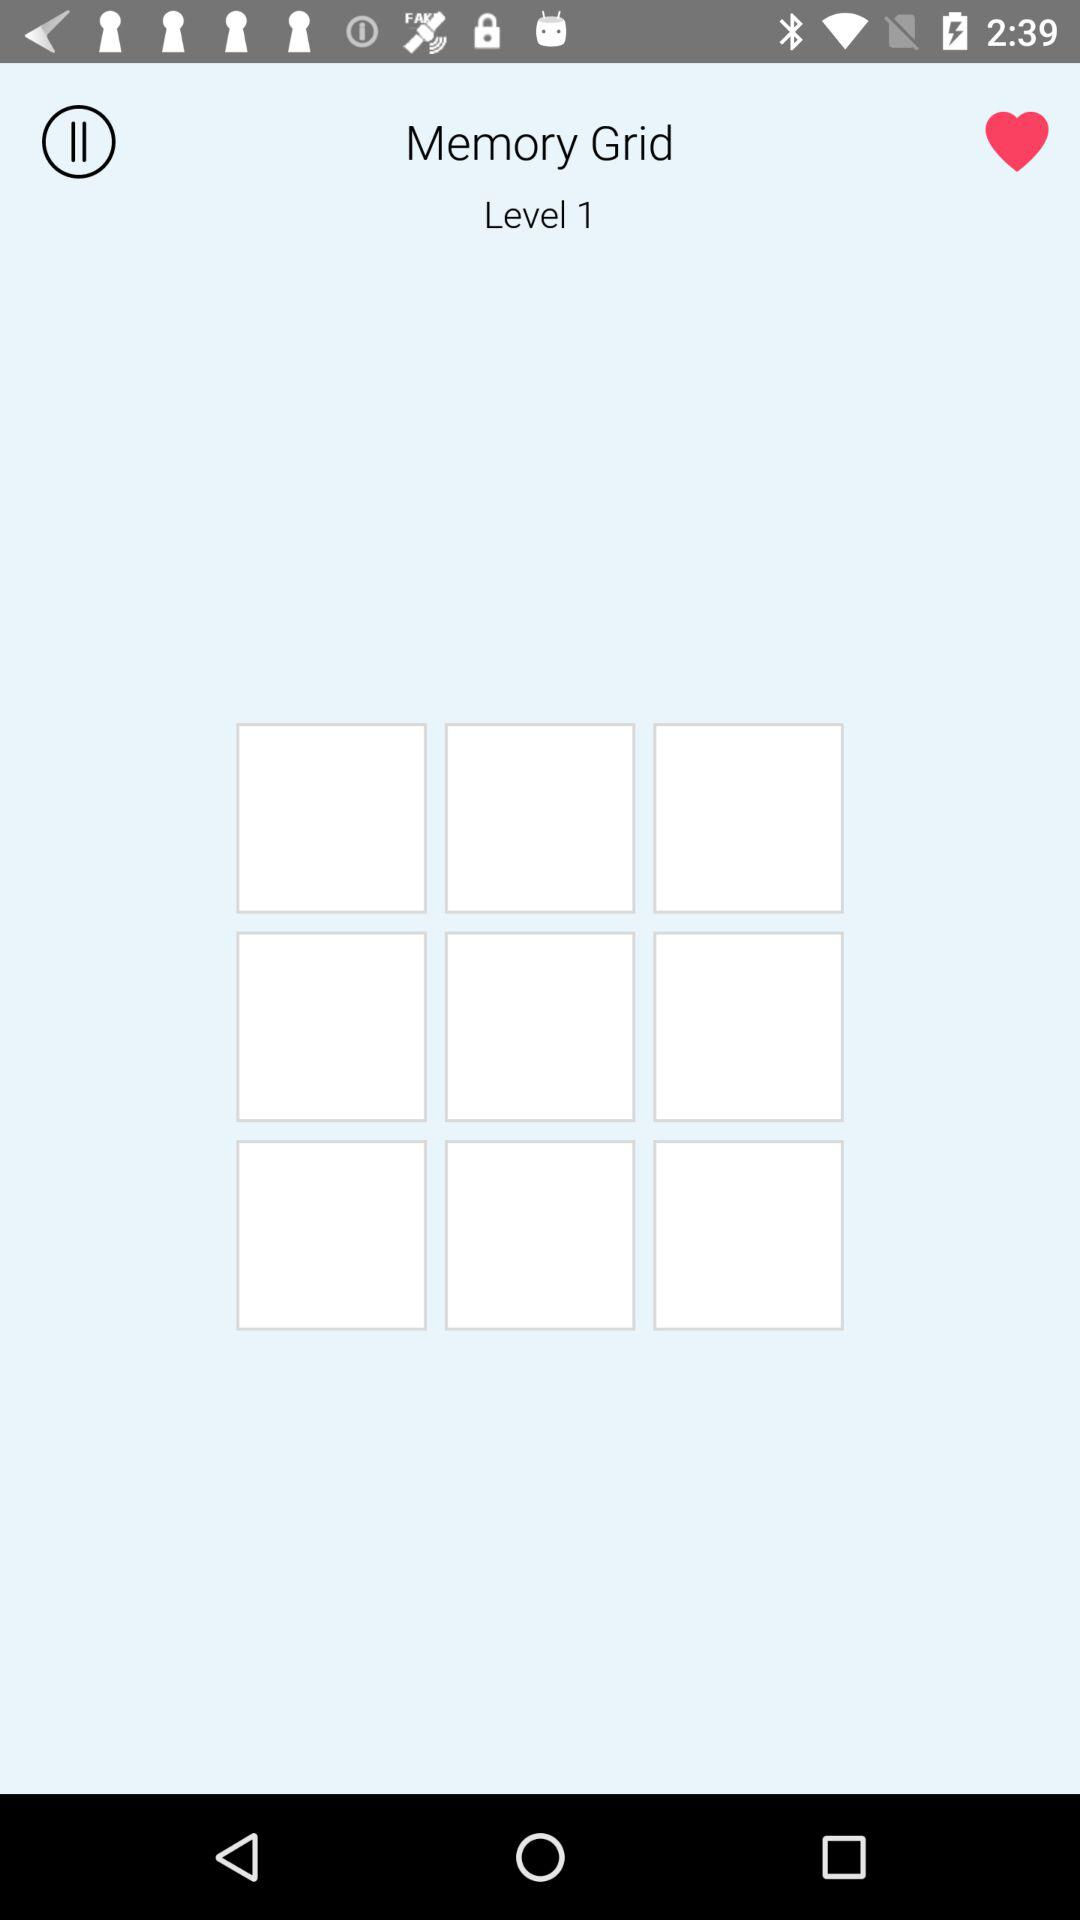How many white rectangles are there in the top row?
Answer the question using a single word or phrase. 3 